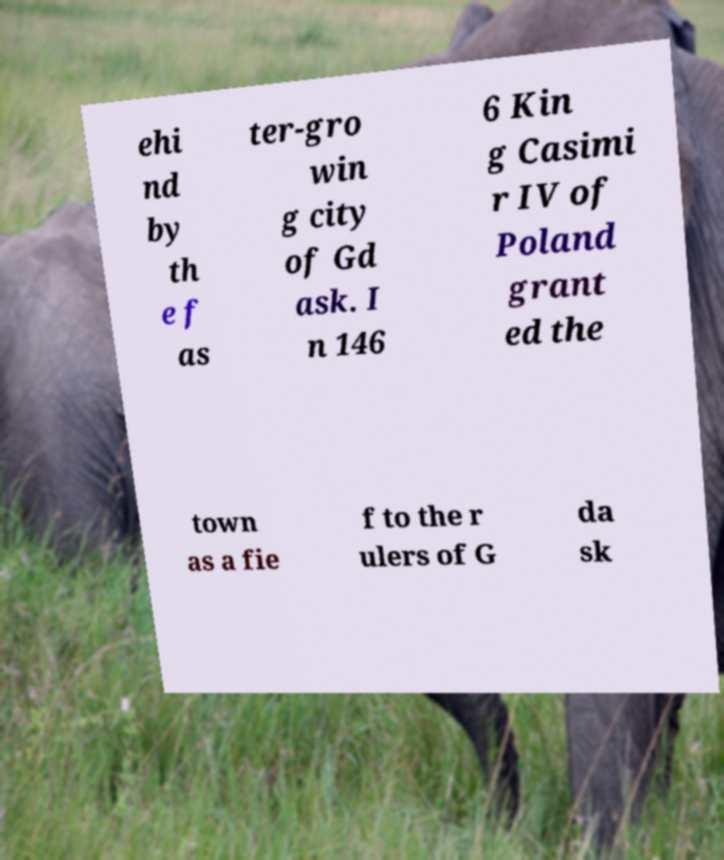There's text embedded in this image that I need extracted. Can you transcribe it verbatim? ehi nd by th e f as ter-gro win g city of Gd ask. I n 146 6 Kin g Casimi r IV of Poland grant ed the town as a fie f to the r ulers of G da sk 